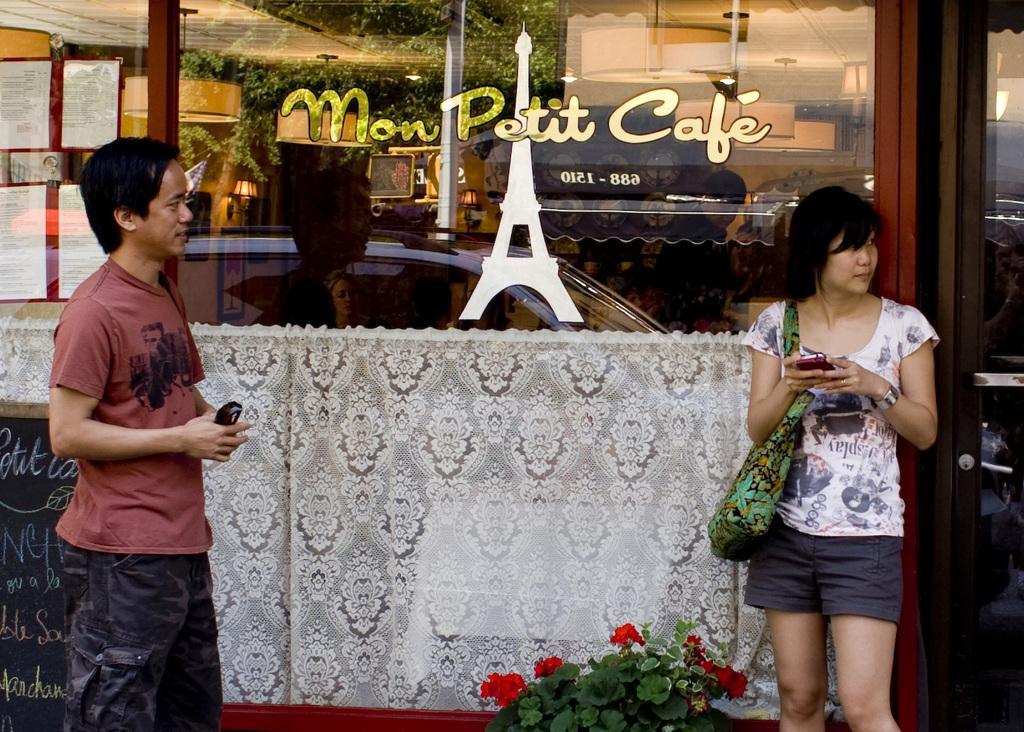Please provide a concise description of this image. In the image we can see there are people standing and they are holding mobile phones in their hand. Behind there is glass window and there is a picture of eiffel tower. There are flowers on the plants. 